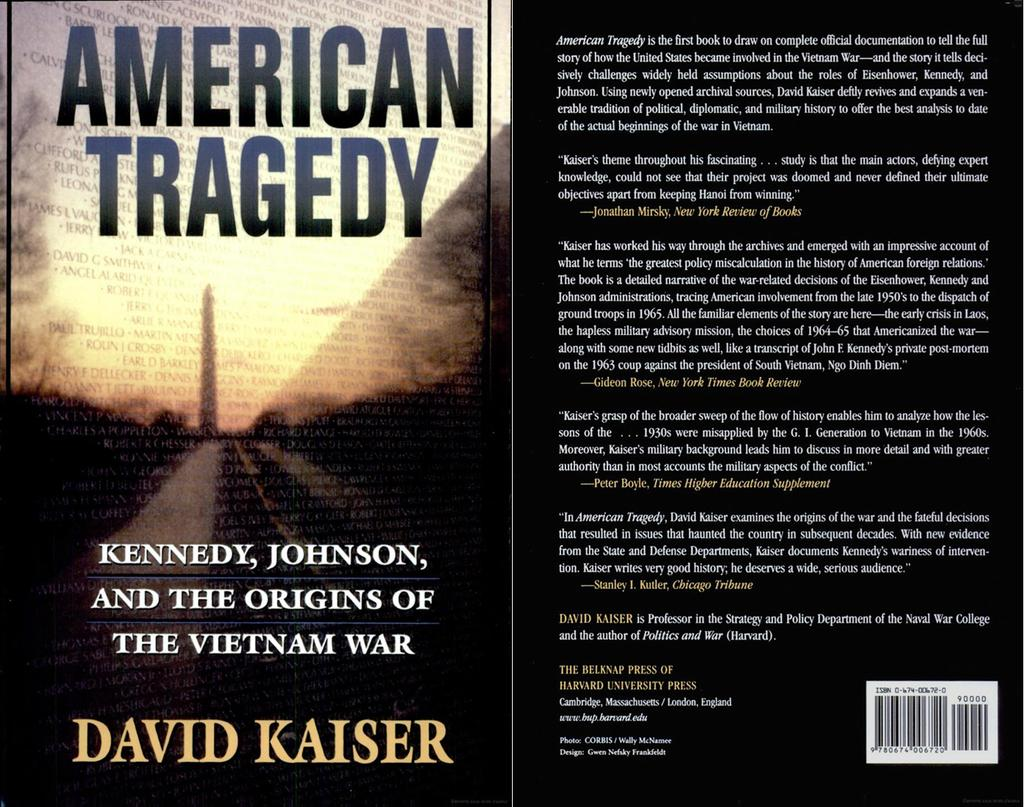<image>
Share a concise interpretation of the image provided. A book is displayed with the title of, "American Tragedy." 